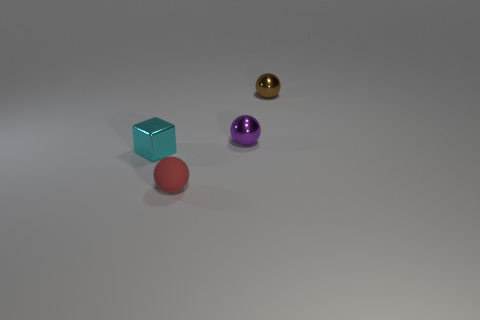Subtract all red matte spheres. How many spheres are left? 2 Add 3 small cyan things. How many objects exist? 7 Subtract all brown balls. How many balls are left? 2 Subtract all balls. How many objects are left? 1 Subtract all purple blocks. Subtract all cyan cylinders. How many blocks are left? 1 Subtract all small red balls. Subtract all shiny cubes. How many objects are left? 2 Add 2 cyan cubes. How many cyan cubes are left? 3 Add 2 purple metallic balls. How many purple metallic balls exist? 3 Subtract 0 brown cubes. How many objects are left? 4 